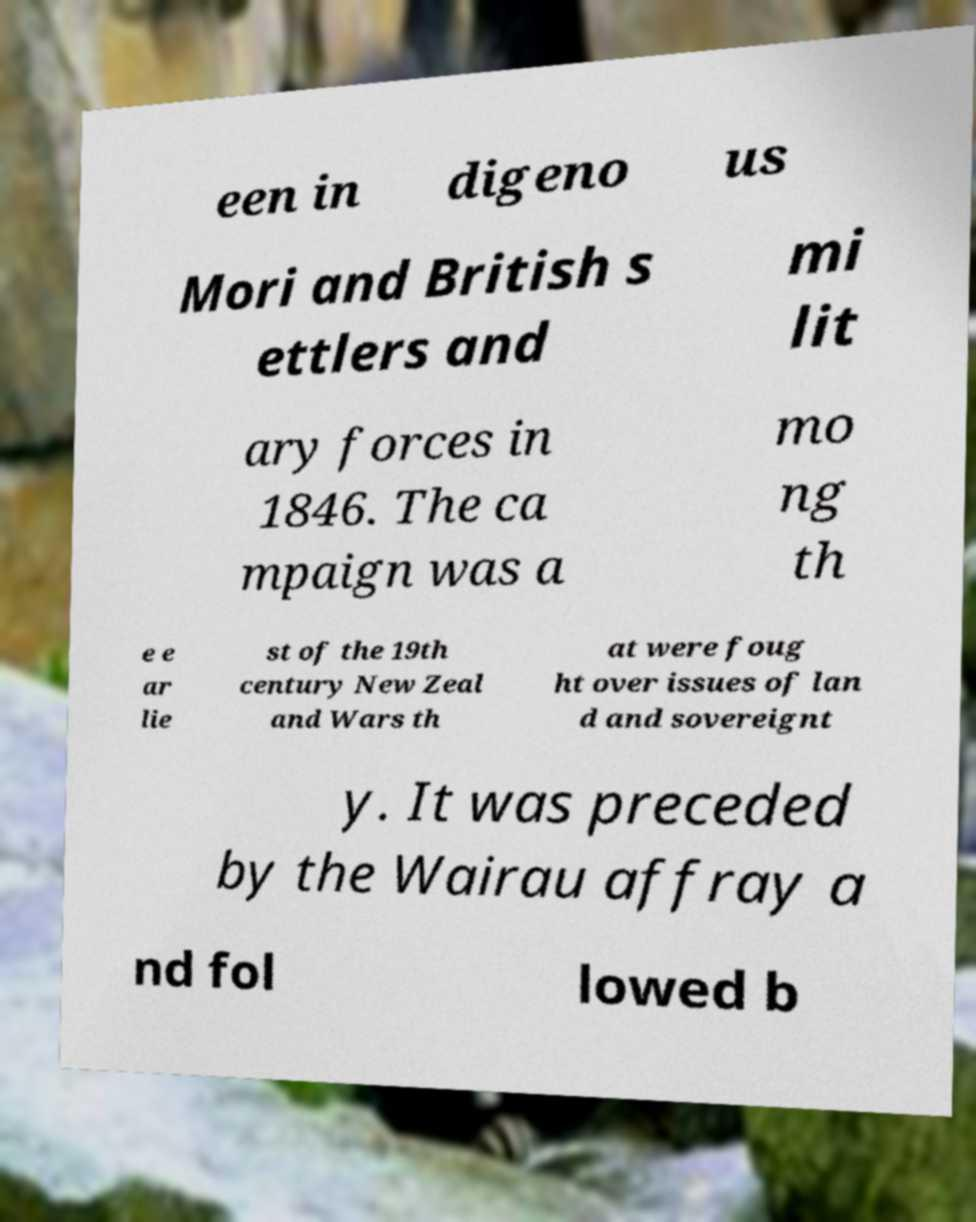Can you accurately transcribe the text from the provided image for me? een in digeno us Mori and British s ettlers and mi lit ary forces in 1846. The ca mpaign was a mo ng th e e ar lie st of the 19th century New Zeal and Wars th at were foug ht over issues of lan d and sovereignt y. It was preceded by the Wairau affray a nd fol lowed b 